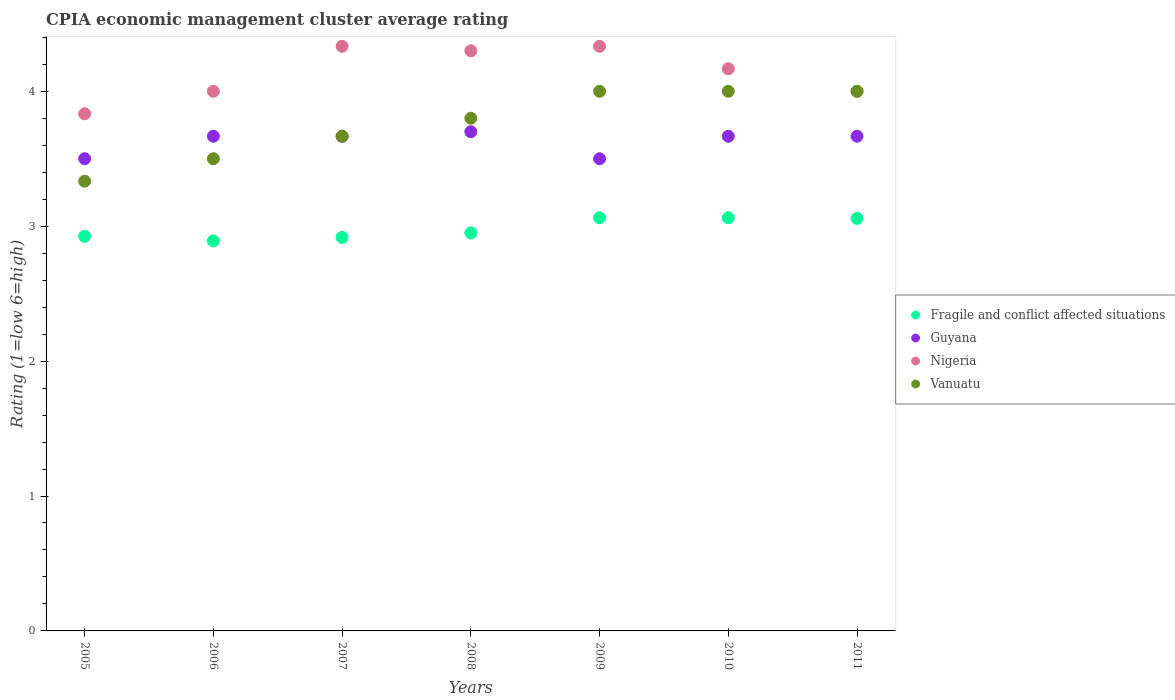What is the CPIA rating in Guyana in 2006?
Keep it short and to the point. 3.67. Across all years, what is the maximum CPIA rating in Nigeria?
Keep it short and to the point. 4.33. Across all years, what is the minimum CPIA rating in Vanuatu?
Provide a succinct answer. 3.33. In which year was the CPIA rating in Vanuatu maximum?
Offer a very short reply. 2009. In which year was the CPIA rating in Nigeria minimum?
Offer a terse response. 2005. What is the total CPIA rating in Fragile and conflict affected situations in the graph?
Keep it short and to the point. 20.87. What is the difference between the CPIA rating in Guyana in 2008 and that in 2010?
Provide a short and direct response. 0.03. What is the difference between the CPIA rating in Nigeria in 2008 and the CPIA rating in Vanuatu in 2009?
Keep it short and to the point. 0.3. What is the average CPIA rating in Guyana per year?
Offer a very short reply. 3.62. What is the ratio of the CPIA rating in Fragile and conflict affected situations in 2009 to that in 2011?
Your answer should be compact. 1. Is the CPIA rating in Vanuatu in 2007 less than that in 2011?
Make the answer very short. Yes. Is the difference between the CPIA rating in Guyana in 2009 and 2011 greater than the difference between the CPIA rating in Vanuatu in 2009 and 2011?
Offer a very short reply. No. What is the difference between the highest and the second highest CPIA rating in Vanuatu?
Make the answer very short. 0. What is the difference between the highest and the lowest CPIA rating in Guyana?
Offer a terse response. 0.2. In how many years, is the CPIA rating in Guyana greater than the average CPIA rating in Guyana taken over all years?
Your answer should be very brief. 5. Is the sum of the CPIA rating in Nigeria in 2005 and 2011 greater than the maximum CPIA rating in Guyana across all years?
Offer a very short reply. Yes. Is it the case that in every year, the sum of the CPIA rating in Vanuatu and CPIA rating in Fragile and conflict affected situations  is greater than the sum of CPIA rating in Guyana and CPIA rating in Nigeria?
Your response must be concise. No. How many dotlines are there?
Keep it short and to the point. 4. How many years are there in the graph?
Keep it short and to the point. 7. What is the difference between two consecutive major ticks on the Y-axis?
Ensure brevity in your answer.  1. Are the values on the major ticks of Y-axis written in scientific E-notation?
Your response must be concise. No. Does the graph contain grids?
Give a very brief answer. No. How many legend labels are there?
Keep it short and to the point. 4. What is the title of the graph?
Your answer should be compact. CPIA economic management cluster average rating. Does "Luxembourg" appear as one of the legend labels in the graph?
Give a very brief answer. No. What is the label or title of the X-axis?
Your response must be concise. Years. What is the Rating (1=low 6=high) of Fragile and conflict affected situations in 2005?
Provide a succinct answer. 2.92. What is the Rating (1=low 6=high) of Nigeria in 2005?
Offer a very short reply. 3.83. What is the Rating (1=low 6=high) of Vanuatu in 2005?
Your response must be concise. 3.33. What is the Rating (1=low 6=high) in Fragile and conflict affected situations in 2006?
Provide a short and direct response. 2.89. What is the Rating (1=low 6=high) of Guyana in 2006?
Ensure brevity in your answer.  3.67. What is the Rating (1=low 6=high) of Nigeria in 2006?
Provide a short and direct response. 4. What is the Rating (1=low 6=high) in Fragile and conflict affected situations in 2007?
Your answer should be compact. 2.92. What is the Rating (1=low 6=high) in Guyana in 2007?
Give a very brief answer. 3.67. What is the Rating (1=low 6=high) of Nigeria in 2007?
Your answer should be very brief. 4.33. What is the Rating (1=low 6=high) of Vanuatu in 2007?
Offer a very short reply. 3.67. What is the Rating (1=low 6=high) in Fragile and conflict affected situations in 2008?
Offer a very short reply. 2.95. What is the Rating (1=low 6=high) in Nigeria in 2008?
Make the answer very short. 4.3. What is the Rating (1=low 6=high) in Fragile and conflict affected situations in 2009?
Offer a terse response. 3.06. What is the Rating (1=low 6=high) of Guyana in 2009?
Offer a terse response. 3.5. What is the Rating (1=low 6=high) in Nigeria in 2009?
Provide a succinct answer. 4.33. What is the Rating (1=low 6=high) in Fragile and conflict affected situations in 2010?
Provide a short and direct response. 3.06. What is the Rating (1=low 6=high) of Guyana in 2010?
Provide a succinct answer. 3.67. What is the Rating (1=low 6=high) in Nigeria in 2010?
Ensure brevity in your answer.  4.17. What is the Rating (1=low 6=high) in Fragile and conflict affected situations in 2011?
Provide a succinct answer. 3.06. What is the Rating (1=low 6=high) in Guyana in 2011?
Provide a short and direct response. 3.67. What is the Rating (1=low 6=high) in Vanuatu in 2011?
Provide a succinct answer. 4. Across all years, what is the maximum Rating (1=low 6=high) of Fragile and conflict affected situations?
Your answer should be compact. 3.06. Across all years, what is the maximum Rating (1=low 6=high) of Guyana?
Provide a short and direct response. 3.7. Across all years, what is the maximum Rating (1=low 6=high) in Nigeria?
Offer a terse response. 4.33. Across all years, what is the maximum Rating (1=low 6=high) of Vanuatu?
Make the answer very short. 4. Across all years, what is the minimum Rating (1=low 6=high) in Fragile and conflict affected situations?
Offer a very short reply. 2.89. Across all years, what is the minimum Rating (1=low 6=high) in Nigeria?
Offer a terse response. 3.83. Across all years, what is the minimum Rating (1=low 6=high) in Vanuatu?
Provide a short and direct response. 3.33. What is the total Rating (1=low 6=high) of Fragile and conflict affected situations in the graph?
Ensure brevity in your answer.  20.87. What is the total Rating (1=low 6=high) in Guyana in the graph?
Keep it short and to the point. 25.37. What is the total Rating (1=low 6=high) in Nigeria in the graph?
Make the answer very short. 28.97. What is the total Rating (1=low 6=high) in Vanuatu in the graph?
Ensure brevity in your answer.  26.3. What is the difference between the Rating (1=low 6=high) of Fragile and conflict affected situations in 2005 and that in 2006?
Offer a very short reply. 0.03. What is the difference between the Rating (1=low 6=high) of Vanuatu in 2005 and that in 2006?
Provide a short and direct response. -0.17. What is the difference between the Rating (1=low 6=high) in Fragile and conflict affected situations in 2005 and that in 2007?
Keep it short and to the point. 0.01. What is the difference between the Rating (1=low 6=high) in Vanuatu in 2005 and that in 2007?
Offer a very short reply. -0.33. What is the difference between the Rating (1=low 6=high) in Fragile and conflict affected situations in 2005 and that in 2008?
Provide a short and direct response. -0.03. What is the difference between the Rating (1=low 6=high) of Nigeria in 2005 and that in 2008?
Your response must be concise. -0.47. What is the difference between the Rating (1=low 6=high) in Vanuatu in 2005 and that in 2008?
Offer a very short reply. -0.47. What is the difference between the Rating (1=low 6=high) in Fragile and conflict affected situations in 2005 and that in 2009?
Your answer should be compact. -0.14. What is the difference between the Rating (1=low 6=high) of Guyana in 2005 and that in 2009?
Provide a short and direct response. 0. What is the difference between the Rating (1=low 6=high) of Fragile and conflict affected situations in 2005 and that in 2010?
Offer a terse response. -0.14. What is the difference between the Rating (1=low 6=high) of Nigeria in 2005 and that in 2010?
Your answer should be compact. -0.33. What is the difference between the Rating (1=low 6=high) in Vanuatu in 2005 and that in 2010?
Keep it short and to the point. -0.67. What is the difference between the Rating (1=low 6=high) of Fragile and conflict affected situations in 2005 and that in 2011?
Your answer should be compact. -0.13. What is the difference between the Rating (1=low 6=high) in Nigeria in 2005 and that in 2011?
Offer a very short reply. -0.17. What is the difference between the Rating (1=low 6=high) in Vanuatu in 2005 and that in 2011?
Give a very brief answer. -0.67. What is the difference between the Rating (1=low 6=high) of Fragile and conflict affected situations in 2006 and that in 2007?
Provide a short and direct response. -0.03. What is the difference between the Rating (1=low 6=high) in Guyana in 2006 and that in 2007?
Provide a short and direct response. 0. What is the difference between the Rating (1=low 6=high) in Fragile and conflict affected situations in 2006 and that in 2008?
Make the answer very short. -0.06. What is the difference between the Rating (1=low 6=high) in Guyana in 2006 and that in 2008?
Provide a succinct answer. -0.03. What is the difference between the Rating (1=low 6=high) of Fragile and conflict affected situations in 2006 and that in 2009?
Offer a very short reply. -0.17. What is the difference between the Rating (1=low 6=high) in Guyana in 2006 and that in 2009?
Provide a short and direct response. 0.17. What is the difference between the Rating (1=low 6=high) in Vanuatu in 2006 and that in 2009?
Offer a terse response. -0.5. What is the difference between the Rating (1=low 6=high) in Fragile and conflict affected situations in 2006 and that in 2010?
Provide a short and direct response. -0.17. What is the difference between the Rating (1=low 6=high) in Vanuatu in 2006 and that in 2010?
Your answer should be very brief. -0.5. What is the difference between the Rating (1=low 6=high) of Fragile and conflict affected situations in 2006 and that in 2011?
Make the answer very short. -0.17. What is the difference between the Rating (1=low 6=high) in Guyana in 2006 and that in 2011?
Your response must be concise. 0. What is the difference between the Rating (1=low 6=high) in Nigeria in 2006 and that in 2011?
Provide a short and direct response. 0. What is the difference between the Rating (1=low 6=high) of Vanuatu in 2006 and that in 2011?
Ensure brevity in your answer.  -0.5. What is the difference between the Rating (1=low 6=high) of Fragile and conflict affected situations in 2007 and that in 2008?
Make the answer very short. -0.03. What is the difference between the Rating (1=low 6=high) of Guyana in 2007 and that in 2008?
Provide a succinct answer. -0.03. What is the difference between the Rating (1=low 6=high) in Vanuatu in 2007 and that in 2008?
Offer a very short reply. -0.13. What is the difference between the Rating (1=low 6=high) of Fragile and conflict affected situations in 2007 and that in 2009?
Make the answer very short. -0.15. What is the difference between the Rating (1=low 6=high) of Guyana in 2007 and that in 2009?
Your answer should be compact. 0.17. What is the difference between the Rating (1=low 6=high) of Nigeria in 2007 and that in 2009?
Provide a succinct answer. 0. What is the difference between the Rating (1=low 6=high) of Vanuatu in 2007 and that in 2009?
Your answer should be compact. -0.33. What is the difference between the Rating (1=low 6=high) of Fragile and conflict affected situations in 2007 and that in 2010?
Your answer should be compact. -0.15. What is the difference between the Rating (1=low 6=high) of Vanuatu in 2007 and that in 2010?
Give a very brief answer. -0.33. What is the difference between the Rating (1=low 6=high) in Fragile and conflict affected situations in 2007 and that in 2011?
Your answer should be very brief. -0.14. What is the difference between the Rating (1=low 6=high) of Guyana in 2007 and that in 2011?
Offer a terse response. 0. What is the difference between the Rating (1=low 6=high) of Vanuatu in 2007 and that in 2011?
Provide a short and direct response. -0.33. What is the difference between the Rating (1=low 6=high) of Fragile and conflict affected situations in 2008 and that in 2009?
Your response must be concise. -0.11. What is the difference between the Rating (1=low 6=high) in Nigeria in 2008 and that in 2009?
Offer a very short reply. -0.03. What is the difference between the Rating (1=low 6=high) in Vanuatu in 2008 and that in 2009?
Your response must be concise. -0.2. What is the difference between the Rating (1=low 6=high) in Fragile and conflict affected situations in 2008 and that in 2010?
Ensure brevity in your answer.  -0.11. What is the difference between the Rating (1=low 6=high) of Guyana in 2008 and that in 2010?
Your answer should be very brief. 0.03. What is the difference between the Rating (1=low 6=high) in Nigeria in 2008 and that in 2010?
Provide a succinct answer. 0.13. What is the difference between the Rating (1=low 6=high) of Fragile and conflict affected situations in 2008 and that in 2011?
Provide a short and direct response. -0.11. What is the difference between the Rating (1=low 6=high) of Nigeria in 2008 and that in 2011?
Your answer should be compact. 0.3. What is the difference between the Rating (1=low 6=high) in Fragile and conflict affected situations in 2009 and that in 2010?
Give a very brief answer. 0. What is the difference between the Rating (1=low 6=high) in Vanuatu in 2009 and that in 2010?
Ensure brevity in your answer.  0. What is the difference between the Rating (1=low 6=high) of Fragile and conflict affected situations in 2009 and that in 2011?
Provide a succinct answer. 0. What is the difference between the Rating (1=low 6=high) in Fragile and conflict affected situations in 2010 and that in 2011?
Your answer should be compact. 0. What is the difference between the Rating (1=low 6=high) in Nigeria in 2010 and that in 2011?
Offer a very short reply. 0.17. What is the difference between the Rating (1=low 6=high) of Vanuatu in 2010 and that in 2011?
Make the answer very short. 0. What is the difference between the Rating (1=low 6=high) of Fragile and conflict affected situations in 2005 and the Rating (1=low 6=high) of Guyana in 2006?
Provide a short and direct response. -0.74. What is the difference between the Rating (1=low 6=high) in Fragile and conflict affected situations in 2005 and the Rating (1=low 6=high) in Nigeria in 2006?
Your answer should be very brief. -1.07. What is the difference between the Rating (1=low 6=high) in Fragile and conflict affected situations in 2005 and the Rating (1=low 6=high) in Vanuatu in 2006?
Ensure brevity in your answer.  -0.57. What is the difference between the Rating (1=low 6=high) in Guyana in 2005 and the Rating (1=low 6=high) in Nigeria in 2006?
Your response must be concise. -0.5. What is the difference between the Rating (1=low 6=high) of Guyana in 2005 and the Rating (1=low 6=high) of Vanuatu in 2006?
Keep it short and to the point. 0. What is the difference between the Rating (1=low 6=high) of Nigeria in 2005 and the Rating (1=low 6=high) of Vanuatu in 2006?
Provide a short and direct response. 0.33. What is the difference between the Rating (1=low 6=high) of Fragile and conflict affected situations in 2005 and the Rating (1=low 6=high) of Guyana in 2007?
Your answer should be very brief. -0.74. What is the difference between the Rating (1=low 6=high) of Fragile and conflict affected situations in 2005 and the Rating (1=low 6=high) of Nigeria in 2007?
Your response must be concise. -1.41. What is the difference between the Rating (1=low 6=high) in Fragile and conflict affected situations in 2005 and the Rating (1=low 6=high) in Vanuatu in 2007?
Offer a terse response. -0.74. What is the difference between the Rating (1=low 6=high) of Guyana in 2005 and the Rating (1=low 6=high) of Nigeria in 2007?
Provide a short and direct response. -0.83. What is the difference between the Rating (1=low 6=high) in Nigeria in 2005 and the Rating (1=low 6=high) in Vanuatu in 2007?
Make the answer very short. 0.17. What is the difference between the Rating (1=low 6=high) in Fragile and conflict affected situations in 2005 and the Rating (1=low 6=high) in Guyana in 2008?
Offer a terse response. -0.78. What is the difference between the Rating (1=low 6=high) of Fragile and conflict affected situations in 2005 and the Rating (1=low 6=high) of Nigeria in 2008?
Provide a succinct answer. -1.38. What is the difference between the Rating (1=low 6=high) in Fragile and conflict affected situations in 2005 and the Rating (1=low 6=high) in Vanuatu in 2008?
Your response must be concise. -0.88. What is the difference between the Rating (1=low 6=high) of Nigeria in 2005 and the Rating (1=low 6=high) of Vanuatu in 2008?
Make the answer very short. 0.03. What is the difference between the Rating (1=low 6=high) in Fragile and conflict affected situations in 2005 and the Rating (1=low 6=high) in Guyana in 2009?
Offer a very short reply. -0.57. What is the difference between the Rating (1=low 6=high) in Fragile and conflict affected situations in 2005 and the Rating (1=low 6=high) in Nigeria in 2009?
Offer a terse response. -1.41. What is the difference between the Rating (1=low 6=high) of Fragile and conflict affected situations in 2005 and the Rating (1=low 6=high) of Vanuatu in 2009?
Provide a succinct answer. -1.07. What is the difference between the Rating (1=low 6=high) in Guyana in 2005 and the Rating (1=low 6=high) in Vanuatu in 2009?
Offer a very short reply. -0.5. What is the difference between the Rating (1=low 6=high) of Fragile and conflict affected situations in 2005 and the Rating (1=low 6=high) of Guyana in 2010?
Your response must be concise. -0.74. What is the difference between the Rating (1=low 6=high) in Fragile and conflict affected situations in 2005 and the Rating (1=low 6=high) in Nigeria in 2010?
Ensure brevity in your answer.  -1.24. What is the difference between the Rating (1=low 6=high) of Fragile and conflict affected situations in 2005 and the Rating (1=low 6=high) of Vanuatu in 2010?
Provide a short and direct response. -1.07. What is the difference between the Rating (1=low 6=high) in Guyana in 2005 and the Rating (1=low 6=high) in Vanuatu in 2010?
Your answer should be very brief. -0.5. What is the difference between the Rating (1=low 6=high) of Nigeria in 2005 and the Rating (1=low 6=high) of Vanuatu in 2010?
Ensure brevity in your answer.  -0.17. What is the difference between the Rating (1=low 6=high) of Fragile and conflict affected situations in 2005 and the Rating (1=low 6=high) of Guyana in 2011?
Your answer should be very brief. -0.74. What is the difference between the Rating (1=low 6=high) in Fragile and conflict affected situations in 2005 and the Rating (1=low 6=high) in Nigeria in 2011?
Provide a short and direct response. -1.07. What is the difference between the Rating (1=low 6=high) of Fragile and conflict affected situations in 2005 and the Rating (1=low 6=high) of Vanuatu in 2011?
Give a very brief answer. -1.07. What is the difference between the Rating (1=low 6=high) of Guyana in 2005 and the Rating (1=low 6=high) of Nigeria in 2011?
Your answer should be compact. -0.5. What is the difference between the Rating (1=low 6=high) of Guyana in 2005 and the Rating (1=low 6=high) of Vanuatu in 2011?
Provide a succinct answer. -0.5. What is the difference between the Rating (1=low 6=high) in Nigeria in 2005 and the Rating (1=low 6=high) in Vanuatu in 2011?
Offer a very short reply. -0.17. What is the difference between the Rating (1=low 6=high) of Fragile and conflict affected situations in 2006 and the Rating (1=low 6=high) of Guyana in 2007?
Offer a terse response. -0.78. What is the difference between the Rating (1=low 6=high) in Fragile and conflict affected situations in 2006 and the Rating (1=low 6=high) in Nigeria in 2007?
Give a very brief answer. -1.44. What is the difference between the Rating (1=low 6=high) in Fragile and conflict affected situations in 2006 and the Rating (1=low 6=high) in Vanuatu in 2007?
Make the answer very short. -0.78. What is the difference between the Rating (1=low 6=high) in Guyana in 2006 and the Rating (1=low 6=high) in Nigeria in 2007?
Ensure brevity in your answer.  -0.67. What is the difference between the Rating (1=low 6=high) of Nigeria in 2006 and the Rating (1=low 6=high) of Vanuatu in 2007?
Ensure brevity in your answer.  0.33. What is the difference between the Rating (1=low 6=high) in Fragile and conflict affected situations in 2006 and the Rating (1=low 6=high) in Guyana in 2008?
Offer a terse response. -0.81. What is the difference between the Rating (1=low 6=high) of Fragile and conflict affected situations in 2006 and the Rating (1=low 6=high) of Nigeria in 2008?
Offer a terse response. -1.41. What is the difference between the Rating (1=low 6=high) in Fragile and conflict affected situations in 2006 and the Rating (1=low 6=high) in Vanuatu in 2008?
Ensure brevity in your answer.  -0.91. What is the difference between the Rating (1=low 6=high) of Guyana in 2006 and the Rating (1=low 6=high) of Nigeria in 2008?
Offer a terse response. -0.63. What is the difference between the Rating (1=low 6=high) in Guyana in 2006 and the Rating (1=low 6=high) in Vanuatu in 2008?
Your answer should be compact. -0.13. What is the difference between the Rating (1=low 6=high) in Fragile and conflict affected situations in 2006 and the Rating (1=low 6=high) in Guyana in 2009?
Your answer should be very brief. -0.61. What is the difference between the Rating (1=low 6=high) of Fragile and conflict affected situations in 2006 and the Rating (1=low 6=high) of Nigeria in 2009?
Your response must be concise. -1.44. What is the difference between the Rating (1=low 6=high) in Fragile and conflict affected situations in 2006 and the Rating (1=low 6=high) in Vanuatu in 2009?
Keep it short and to the point. -1.11. What is the difference between the Rating (1=low 6=high) in Guyana in 2006 and the Rating (1=low 6=high) in Nigeria in 2009?
Your response must be concise. -0.67. What is the difference between the Rating (1=low 6=high) in Guyana in 2006 and the Rating (1=low 6=high) in Vanuatu in 2009?
Provide a succinct answer. -0.33. What is the difference between the Rating (1=low 6=high) in Nigeria in 2006 and the Rating (1=low 6=high) in Vanuatu in 2009?
Keep it short and to the point. 0. What is the difference between the Rating (1=low 6=high) in Fragile and conflict affected situations in 2006 and the Rating (1=low 6=high) in Guyana in 2010?
Ensure brevity in your answer.  -0.78. What is the difference between the Rating (1=low 6=high) in Fragile and conflict affected situations in 2006 and the Rating (1=low 6=high) in Nigeria in 2010?
Provide a succinct answer. -1.28. What is the difference between the Rating (1=low 6=high) in Fragile and conflict affected situations in 2006 and the Rating (1=low 6=high) in Vanuatu in 2010?
Your answer should be very brief. -1.11. What is the difference between the Rating (1=low 6=high) in Guyana in 2006 and the Rating (1=low 6=high) in Nigeria in 2010?
Make the answer very short. -0.5. What is the difference between the Rating (1=low 6=high) in Guyana in 2006 and the Rating (1=low 6=high) in Vanuatu in 2010?
Provide a succinct answer. -0.33. What is the difference between the Rating (1=low 6=high) of Fragile and conflict affected situations in 2006 and the Rating (1=low 6=high) of Guyana in 2011?
Make the answer very short. -0.78. What is the difference between the Rating (1=low 6=high) of Fragile and conflict affected situations in 2006 and the Rating (1=low 6=high) of Nigeria in 2011?
Your answer should be compact. -1.11. What is the difference between the Rating (1=low 6=high) of Fragile and conflict affected situations in 2006 and the Rating (1=low 6=high) of Vanuatu in 2011?
Make the answer very short. -1.11. What is the difference between the Rating (1=low 6=high) in Fragile and conflict affected situations in 2007 and the Rating (1=low 6=high) in Guyana in 2008?
Offer a terse response. -0.78. What is the difference between the Rating (1=low 6=high) of Fragile and conflict affected situations in 2007 and the Rating (1=low 6=high) of Nigeria in 2008?
Keep it short and to the point. -1.38. What is the difference between the Rating (1=low 6=high) in Fragile and conflict affected situations in 2007 and the Rating (1=low 6=high) in Vanuatu in 2008?
Give a very brief answer. -0.88. What is the difference between the Rating (1=low 6=high) of Guyana in 2007 and the Rating (1=low 6=high) of Nigeria in 2008?
Your answer should be very brief. -0.63. What is the difference between the Rating (1=low 6=high) of Guyana in 2007 and the Rating (1=low 6=high) of Vanuatu in 2008?
Ensure brevity in your answer.  -0.13. What is the difference between the Rating (1=low 6=high) in Nigeria in 2007 and the Rating (1=low 6=high) in Vanuatu in 2008?
Your answer should be very brief. 0.53. What is the difference between the Rating (1=low 6=high) in Fragile and conflict affected situations in 2007 and the Rating (1=low 6=high) in Guyana in 2009?
Your response must be concise. -0.58. What is the difference between the Rating (1=low 6=high) in Fragile and conflict affected situations in 2007 and the Rating (1=low 6=high) in Nigeria in 2009?
Provide a short and direct response. -1.42. What is the difference between the Rating (1=low 6=high) in Fragile and conflict affected situations in 2007 and the Rating (1=low 6=high) in Vanuatu in 2009?
Provide a succinct answer. -1.08. What is the difference between the Rating (1=low 6=high) of Guyana in 2007 and the Rating (1=low 6=high) of Nigeria in 2009?
Your answer should be compact. -0.67. What is the difference between the Rating (1=low 6=high) in Fragile and conflict affected situations in 2007 and the Rating (1=low 6=high) in Guyana in 2010?
Keep it short and to the point. -0.75. What is the difference between the Rating (1=low 6=high) of Fragile and conflict affected situations in 2007 and the Rating (1=low 6=high) of Nigeria in 2010?
Provide a succinct answer. -1.25. What is the difference between the Rating (1=low 6=high) of Fragile and conflict affected situations in 2007 and the Rating (1=low 6=high) of Vanuatu in 2010?
Ensure brevity in your answer.  -1.08. What is the difference between the Rating (1=low 6=high) of Nigeria in 2007 and the Rating (1=low 6=high) of Vanuatu in 2010?
Ensure brevity in your answer.  0.33. What is the difference between the Rating (1=low 6=high) in Fragile and conflict affected situations in 2007 and the Rating (1=low 6=high) in Guyana in 2011?
Keep it short and to the point. -0.75. What is the difference between the Rating (1=low 6=high) in Fragile and conflict affected situations in 2007 and the Rating (1=low 6=high) in Nigeria in 2011?
Your answer should be very brief. -1.08. What is the difference between the Rating (1=low 6=high) of Fragile and conflict affected situations in 2007 and the Rating (1=low 6=high) of Vanuatu in 2011?
Your answer should be compact. -1.08. What is the difference between the Rating (1=low 6=high) of Guyana in 2007 and the Rating (1=low 6=high) of Nigeria in 2011?
Ensure brevity in your answer.  -0.33. What is the difference between the Rating (1=low 6=high) of Guyana in 2007 and the Rating (1=low 6=high) of Vanuatu in 2011?
Make the answer very short. -0.33. What is the difference between the Rating (1=low 6=high) in Nigeria in 2007 and the Rating (1=low 6=high) in Vanuatu in 2011?
Provide a short and direct response. 0.33. What is the difference between the Rating (1=low 6=high) in Fragile and conflict affected situations in 2008 and the Rating (1=low 6=high) in Guyana in 2009?
Your answer should be compact. -0.55. What is the difference between the Rating (1=low 6=high) of Fragile and conflict affected situations in 2008 and the Rating (1=low 6=high) of Nigeria in 2009?
Offer a terse response. -1.38. What is the difference between the Rating (1=low 6=high) in Fragile and conflict affected situations in 2008 and the Rating (1=low 6=high) in Vanuatu in 2009?
Offer a terse response. -1.05. What is the difference between the Rating (1=low 6=high) of Guyana in 2008 and the Rating (1=low 6=high) of Nigeria in 2009?
Keep it short and to the point. -0.63. What is the difference between the Rating (1=low 6=high) in Guyana in 2008 and the Rating (1=low 6=high) in Vanuatu in 2009?
Provide a short and direct response. -0.3. What is the difference between the Rating (1=low 6=high) in Nigeria in 2008 and the Rating (1=low 6=high) in Vanuatu in 2009?
Make the answer very short. 0.3. What is the difference between the Rating (1=low 6=high) of Fragile and conflict affected situations in 2008 and the Rating (1=low 6=high) of Guyana in 2010?
Offer a terse response. -0.72. What is the difference between the Rating (1=low 6=high) of Fragile and conflict affected situations in 2008 and the Rating (1=low 6=high) of Nigeria in 2010?
Ensure brevity in your answer.  -1.22. What is the difference between the Rating (1=low 6=high) in Fragile and conflict affected situations in 2008 and the Rating (1=low 6=high) in Vanuatu in 2010?
Keep it short and to the point. -1.05. What is the difference between the Rating (1=low 6=high) in Guyana in 2008 and the Rating (1=low 6=high) in Nigeria in 2010?
Make the answer very short. -0.47. What is the difference between the Rating (1=low 6=high) of Nigeria in 2008 and the Rating (1=low 6=high) of Vanuatu in 2010?
Ensure brevity in your answer.  0.3. What is the difference between the Rating (1=low 6=high) of Fragile and conflict affected situations in 2008 and the Rating (1=low 6=high) of Guyana in 2011?
Ensure brevity in your answer.  -0.72. What is the difference between the Rating (1=low 6=high) in Fragile and conflict affected situations in 2008 and the Rating (1=low 6=high) in Nigeria in 2011?
Your response must be concise. -1.05. What is the difference between the Rating (1=low 6=high) in Fragile and conflict affected situations in 2008 and the Rating (1=low 6=high) in Vanuatu in 2011?
Offer a very short reply. -1.05. What is the difference between the Rating (1=low 6=high) in Guyana in 2008 and the Rating (1=low 6=high) in Vanuatu in 2011?
Your response must be concise. -0.3. What is the difference between the Rating (1=low 6=high) of Fragile and conflict affected situations in 2009 and the Rating (1=low 6=high) of Guyana in 2010?
Ensure brevity in your answer.  -0.6. What is the difference between the Rating (1=low 6=high) in Fragile and conflict affected situations in 2009 and the Rating (1=low 6=high) in Nigeria in 2010?
Provide a short and direct response. -1.1. What is the difference between the Rating (1=low 6=high) in Fragile and conflict affected situations in 2009 and the Rating (1=low 6=high) in Vanuatu in 2010?
Offer a very short reply. -0.94. What is the difference between the Rating (1=low 6=high) in Guyana in 2009 and the Rating (1=low 6=high) in Nigeria in 2010?
Provide a short and direct response. -0.67. What is the difference between the Rating (1=low 6=high) of Fragile and conflict affected situations in 2009 and the Rating (1=low 6=high) of Guyana in 2011?
Make the answer very short. -0.6. What is the difference between the Rating (1=low 6=high) of Fragile and conflict affected situations in 2009 and the Rating (1=low 6=high) of Nigeria in 2011?
Your response must be concise. -0.94. What is the difference between the Rating (1=low 6=high) of Fragile and conflict affected situations in 2009 and the Rating (1=low 6=high) of Vanuatu in 2011?
Offer a terse response. -0.94. What is the difference between the Rating (1=low 6=high) of Guyana in 2009 and the Rating (1=low 6=high) of Nigeria in 2011?
Offer a very short reply. -0.5. What is the difference between the Rating (1=low 6=high) in Guyana in 2009 and the Rating (1=low 6=high) in Vanuatu in 2011?
Give a very brief answer. -0.5. What is the difference between the Rating (1=low 6=high) of Nigeria in 2009 and the Rating (1=low 6=high) of Vanuatu in 2011?
Your answer should be compact. 0.33. What is the difference between the Rating (1=low 6=high) of Fragile and conflict affected situations in 2010 and the Rating (1=low 6=high) of Guyana in 2011?
Make the answer very short. -0.6. What is the difference between the Rating (1=low 6=high) of Fragile and conflict affected situations in 2010 and the Rating (1=low 6=high) of Nigeria in 2011?
Your answer should be compact. -0.94. What is the difference between the Rating (1=low 6=high) of Fragile and conflict affected situations in 2010 and the Rating (1=low 6=high) of Vanuatu in 2011?
Make the answer very short. -0.94. What is the difference between the Rating (1=low 6=high) in Guyana in 2010 and the Rating (1=low 6=high) in Nigeria in 2011?
Offer a very short reply. -0.33. What is the difference between the Rating (1=low 6=high) in Guyana in 2010 and the Rating (1=low 6=high) in Vanuatu in 2011?
Keep it short and to the point. -0.33. What is the difference between the Rating (1=low 6=high) in Nigeria in 2010 and the Rating (1=low 6=high) in Vanuatu in 2011?
Offer a terse response. 0.17. What is the average Rating (1=low 6=high) in Fragile and conflict affected situations per year?
Provide a succinct answer. 2.98. What is the average Rating (1=low 6=high) in Guyana per year?
Offer a very short reply. 3.62. What is the average Rating (1=low 6=high) in Nigeria per year?
Keep it short and to the point. 4.14. What is the average Rating (1=low 6=high) of Vanuatu per year?
Your answer should be very brief. 3.76. In the year 2005, what is the difference between the Rating (1=low 6=high) in Fragile and conflict affected situations and Rating (1=low 6=high) in Guyana?
Provide a short and direct response. -0.57. In the year 2005, what is the difference between the Rating (1=low 6=high) of Fragile and conflict affected situations and Rating (1=low 6=high) of Nigeria?
Provide a succinct answer. -0.91. In the year 2005, what is the difference between the Rating (1=low 6=high) in Fragile and conflict affected situations and Rating (1=low 6=high) in Vanuatu?
Your answer should be compact. -0.41. In the year 2005, what is the difference between the Rating (1=low 6=high) of Guyana and Rating (1=low 6=high) of Vanuatu?
Your response must be concise. 0.17. In the year 2006, what is the difference between the Rating (1=low 6=high) in Fragile and conflict affected situations and Rating (1=low 6=high) in Guyana?
Make the answer very short. -0.78. In the year 2006, what is the difference between the Rating (1=low 6=high) in Fragile and conflict affected situations and Rating (1=low 6=high) in Nigeria?
Your answer should be compact. -1.11. In the year 2006, what is the difference between the Rating (1=low 6=high) of Fragile and conflict affected situations and Rating (1=low 6=high) of Vanuatu?
Provide a short and direct response. -0.61. In the year 2006, what is the difference between the Rating (1=low 6=high) of Guyana and Rating (1=low 6=high) of Nigeria?
Your response must be concise. -0.33. In the year 2007, what is the difference between the Rating (1=low 6=high) in Fragile and conflict affected situations and Rating (1=low 6=high) in Guyana?
Offer a terse response. -0.75. In the year 2007, what is the difference between the Rating (1=low 6=high) in Fragile and conflict affected situations and Rating (1=low 6=high) in Nigeria?
Offer a very short reply. -1.42. In the year 2007, what is the difference between the Rating (1=low 6=high) of Fragile and conflict affected situations and Rating (1=low 6=high) of Vanuatu?
Your answer should be compact. -0.75. In the year 2007, what is the difference between the Rating (1=low 6=high) in Guyana and Rating (1=low 6=high) in Vanuatu?
Ensure brevity in your answer.  0. In the year 2007, what is the difference between the Rating (1=low 6=high) in Nigeria and Rating (1=low 6=high) in Vanuatu?
Keep it short and to the point. 0.67. In the year 2008, what is the difference between the Rating (1=low 6=high) of Fragile and conflict affected situations and Rating (1=low 6=high) of Guyana?
Give a very brief answer. -0.75. In the year 2008, what is the difference between the Rating (1=low 6=high) in Fragile and conflict affected situations and Rating (1=low 6=high) in Nigeria?
Give a very brief answer. -1.35. In the year 2008, what is the difference between the Rating (1=low 6=high) of Fragile and conflict affected situations and Rating (1=low 6=high) of Vanuatu?
Offer a very short reply. -0.85. In the year 2008, what is the difference between the Rating (1=low 6=high) of Guyana and Rating (1=low 6=high) of Nigeria?
Provide a short and direct response. -0.6. In the year 2008, what is the difference between the Rating (1=low 6=high) in Nigeria and Rating (1=low 6=high) in Vanuatu?
Offer a very short reply. 0.5. In the year 2009, what is the difference between the Rating (1=low 6=high) in Fragile and conflict affected situations and Rating (1=low 6=high) in Guyana?
Offer a very short reply. -0.44. In the year 2009, what is the difference between the Rating (1=low 6=high) in Fragile and conflict affected situations and Rating (1=low 6=high) in Nigeria?
Ensure brevity in your answer.  -1.27. In the year 2009, what is the difference between the Rating (1=low 6=high) of Fragile and conflict affected situations and Rating (1=low 6=high) of Vanuatu?
Provide a succinct answer. -0.94. In the year 2009, what is the difference between the Rating (1=low 6=high) of Guyana and Rating (1=low 6=high) of Nigeria?
Offer a terse response. -0.83. In the year 2010, what is the difference between the Rating (1=low 6=high) in Fragile and conflict affected situations and Rating (1=low 6=high) in Guyana?
Give a very brief answer. -0.6. In the year 2010, what is the difference between the Rating (1=low 6=high) of Fragile and conflict affected situations and Rating (1=low 6=high) of Nigeria?
Offer a very short reply. -1.1. In the year 2010, what is the difference between the Rating (1=low 6=high) in Fragile and conflict affected situations and Rating (1=low 6=high) in Vanuatu?
Keep it short and to the point. -0.94. In the year 2011, what is the difference between the Rating (1=low 6=high) in Fragile and conflict affected situations and Rating (1=low 6=high) in Guyana?
Your answer should be compact. -0.61. In the year 2011, what is the difference between the Rating (1=low 6=high) of Fragile and conflict affected situations and Rating (1=low 6=high) of Nigeria?
Keep it short and to the point. -0.94. In the year 2011, what is the difference between the Rating (1=low 6=high) in Fragile and conflict affected situations and Rating (1=low 6=high) in Vanuatu?
Your answer should be compact. -0.94. In the year 2011, what is the difference between the Rating (1=low 6=high) of Guyana and Rating (1=low 6=high) of Nigeria?
Your response must be concise. -0.33. What is the ratio of the Rating (1=low 6=high) in Fragile and conflict affected situations in 2005 to that in 2006?
Keep it short and to the point. 1.01. What is the ratio of the Rating (1=low 6=high) of Guyana in 2005 to that in 2006?
Your answer should be compact. 0.95. What is the ratio of the Rating (1=low 6=high) of Nigeria in 2005 to that in 2006?
Make the answer very short. 0.96. What is the ratio of the Rating (1=low 6=high) in Vanuatu in 2005 to that in 2006?
Your answer should be compact. 0.95. What is the ratio of the Rating (1=low 6=high) of Fragile and conflict affected situations in 2005 to that in 2007?
Provide a short and direct response. 1. What is the ratio of the Rating (1=low 6=high) of Guyana in 2005 to that in 2007?
Your response must be concise. 0.95. What is the ratio of the Rating (1=low 6=high) of Nigeria in 2005 to that in 2007?
Your answer should be compact. 0.88. What is the ratio of the Rating (1=low 6=high) in Vanuatu in 2005 to that in 2007?
Keep it short and to the point. 0.91. What is the ratio of the Rating (1=low 6=high) in Guyana in 2005 to that in 2008?
Make the answer very short. 0.95. What is the ratio of the Rating (1=low 6=high) in Nigeria in 2005 to that in 2008?
Provide a succinct answer. 0.89. What is the ratio of the Rating (1=low 6=high) in Vanuatu in 2005 to that in 2008?
Your response must be concise. 0.88. What is the ratio of the Rating (1=low 6=high) in Fragile and conflict affected situations in 2005 to that in 2009?
Provide a short and direct response. 0.96. What is the ratio of the Rating (1=low 6=high) in Nigeria in 2005 to that in 2009?
Offer a very short reply. 0.88. What is the ratio of the Rating (1=low 6=high) in Fragile and conflict affected situations in 2005 to that in 2010?
Your response must be concise. 0.96. What is the ratio of the Rating (1=low 6=high) in Guyana in 2005 to that in 2010?
Your answer should be very brief. 0.95. What is the ratio of the Rating (1=low 6=high) in Vanuatu in 2005 to that in 2010?
Provide a short and direct response. 0.83. What is the ratio of the Rating (1=low 6=high) in Fragile and conflict affected situations in 2005 to that in 2011?
Offer a terse response. 0.96. What is the ratio of the Rating (1=low 6=high) of Guyana in 2005 to that in 2011?
Your answer should be compact. 0.95. What is the ratio of the Rating (1=low 6=high) of Fragile and conflict affected situations in 2006 to that in 2007?
Ensure brevity in your answer.  0.99. What is the ratio of the Rating (1=low 6=high) of Vanuatu in 2006 to that in 2007?
Offer a terse response. 0.95. What is the ratio of the Rating (1=low 6=high) of Nigeria in 2006 to that in 2008?
Make the answer very short. 0.93. What is the ratio of the Rating (1=low 6=high) of Vanuatu in 2006 to that in 2008?
Offer a terse response. 0.92. What is the ratio of the Rating (1=low 6=high) of Fragile and conflict affected situations in 2006 to that in 2009?
Keep it short and to the point. 0.94. What is the ratio of the Rating (1=low 6=high) of Guyana in 2006 to that in 2009?
Keep it short and to the point. 1.05. What is the ratio of the Rating (1=low 6=high) in Nigeria in 2006 to that in 2009?
Keep it short and to the point. 0.92. What is the ratio of the Rating (1=low 6=high) in Fragile and conflict affected situations in 2006 to that in 2010?
Make the answer very short. 0.94. What is the ratio of the Rating (1=low 6=high) of Guyana in 2006 to that in 2010?
Your answer should be compact. 1. What is the ratio of the Rating (1=low 6=high) of Nigeria in 2006 to that in 2010?
Offer a terse response. 0.96. What is the ratio of the Rating (1=low 6=high) of Fragile and conflict affected situations in 2006 to that in 2011?
Your answer should be very brief. 0.95. What is the ratio of the Rating (1=low 6=high) of Fragile and conflict affected situations in 2007 to that in 2008?
Your answer should be very brief. 0.99. What is the ratio of the Rating (1=low 6=high) of Guyana in 2007 to that in 2008?
Your response must be concise. 0.99. What is the ratio of the Rating (1=low 6=high) of Vanuatu in 2007 to that in 2008?
Provide a succinct answer. 0.96. What is the ratio of the Rating (1=low 6=high) in Fragile and conflict affected situations in 2007 to that in 2009?
Your answer should be very brief. 0.95. What is the ratio of the Rating (1=low 6=high) of Guyana in 2007 to that in 2009?
Make the answer very short. 1.05. What is the ratio of the Rating (1=low 6=high) of Vanuatu in 2007 to that in 2009?
Your answer should be very brief. 0.92. What is the ratio of the Rating (1=low 6=high) of Fragile and conflict affected situations in 2007 to that in 2010?
Give a very brief answer. 0.95. What is the ratio of the Rating (1=low 6=high) in Guyana in 2007 to that in 2010?
Ensure brevity in your answer.  1. What is the ratio of the Rating (1=low 6=high) in Vanuatu in 2007 to that in 2010?
Your answer should be very brief. 0.92. What is the ratio of the Rating (1=low 6=high) of Fragile and conflict affected situations in 2007 to that in 2011?
Your response must be concise. 0.95. What is the ratio of the Rating (1=low 6=high) of Guyana in 2007 to that in 2011?
Offer a terse response. 1. What is the ratio of the Rating (1=low 6=high) of Nigeria in 2007 to that in 2011?
Provide a short and direct response. 1.08. What is the ratio of the Rating (1=low 6=high) in Vanuatu in 2007 to that in 2011?
Provide a succinct answer. 0.92. What is the ratio of the Rating (1=low 6=high) in Fragile and conflict affected situations in 2008 to that in 2009?
Your answer should be very brief. 0.96. What is the ratio of the Rating (1=low 6=high) in Guyana in 2008 to that in 2009?
Ensure brevity in your answer.  1.06. What is the ratio of the Rating (1=low 6=high) of Vanuatu in 2008 to that in 2009?
Ensure brevity in your answer.  0.95. What is the ratio of the Rating (1=low 6=high) of Fragile and conflict affected situations in 2008 to that in 2010?
Give a very brief answer. 0.96. What is the ratio of the Rating (1=low 6=high) of Guyana in 2008 to that in 2010?
Provide a succinct answer. 1.01. What is the ratio of the Rating (1=low 6=high) of Nigeria in 2008 to that in 2010?
Give a very brief answer. 1.03. What is the ratio of the Rating (1=low 6=high) in Vanuatu in 2008 to that in 2010?
Ensure brevity in your answer.  0.95. What is the ratio of the Rating (1=low 6=high) of Fragile and conflict affected situations in 2008 to that in 2011?
Make the answer very short. 0.96. What is the ratio of the Rating (1=low 6=high) in Guyana in 2008 to that in 2011?
Provide a succinct answer. 1.01. What is the ratio of the Rating (1=low 6=high) of Nigeria in 2008 to that in 2011?
Ensure brevity in your answer.  1.07. What is the ratio of the Rating (1=low 6=high) in Guyana in 2009 to that in 2010?
Give a very brief answer. 0.95. What is the ratio of the Rating (1=low 6=high) of Nigeria in 2009 to that in 2010?
Keep it short and to the point. 1.04. What is the ratio of the Rating (1=low 6=high) in Vanuatu in 2009 to that in 2010?
Offer a very short reply. 1. What is the ratio of the Rating (1=low 6=high) of Guyana in 2009 to that in 2011?
Give a very brief answer. 0.95. What is the ratio of the Rating (1=low 6=high) in Vanuatu in 2009 to that in 2011?
Your response must be concise. 1. What is the ratio of the Rating (1=low 6=high) of Fragile and conflict affected situations in 2010 to that in 2011?
Give a very brief answer. 1. What is the ratio of the Rating (1=low 6=high) of Nigeria in 2010 to that in 2011?
Ensure brevity in your answer.  1.04. What is the difference between the highest and the second highest Rating (1=low 6=high) in Fragile and conflict affected situations?
Your response must be concise. 0. What is the difference between the highest and the second highest Rating (1=low 6=high) of Nigeria?
Your answer should be compact. 0. What is the difference between the highest and the second highest Rating (1=low 6=high) in Vanuatu?
Your answer should be very brief. 0. What is the difference between the highest and the lowest Rating (1=low 6=high) of Fragile and conflict affected situations?
Ensure brevity in your answer.  0.17. What is the difference between the highest and the lowest Rating (1=low 6=high) in Guyana?
Offer a terse response. 0.2. What is the difference between the highest and the lowest Rating (1=low 6=high) in Nigeria?
Offer a very short reply. 0.5. 